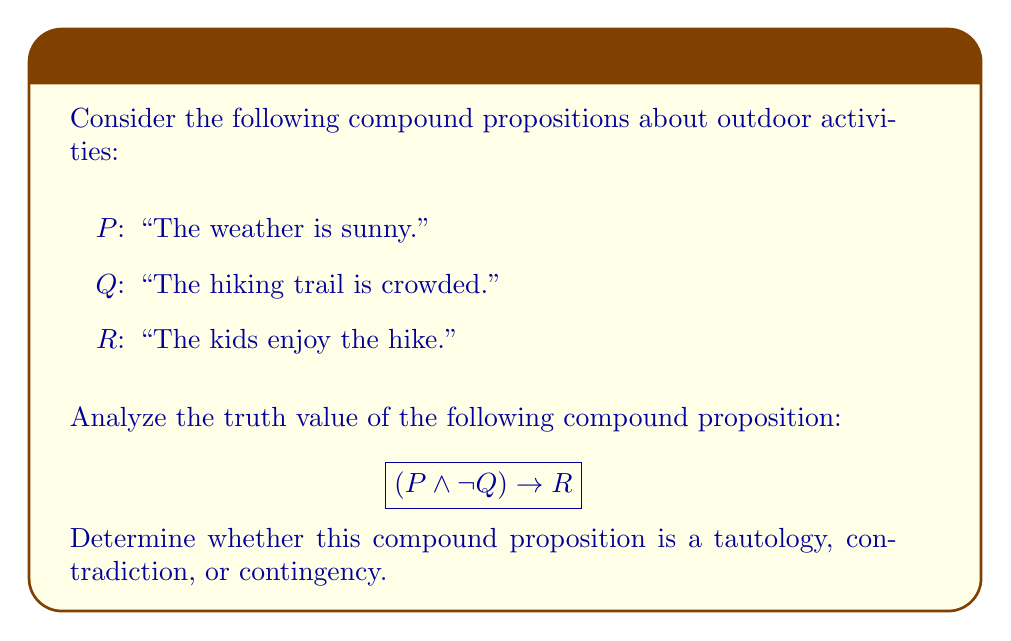Give your solution to this math problem. To analyze the truth value of the given compound proposition, we need to consider all possible combinations of truth values for P, Q, and R. We'll use a truth table to evaluate this:

1. First, let's list all possible combinations of P, Q, and R:

   | P | Q | R |
   |---|---|---|
   | T | T | T |
   | T | T | F |
   | T | F | T |
   | T | F | F |
   | F | T | T |
   | F | T | F |
   | F | F | T |
   | F | F | F |

2. Now, let's evaluate $(P \wedge \neg Q)$ for each row:

   | P | Q | $\neg Q$ | $(P \wedge \neg Q)$ |
   |---|---|---------|---------------------|
   | T | T | F       | F                   |
   | T | T | F       | F                   |
   | T | F | T       | T                   |
   | T | F | T       | T                   |
   | F | T | F       | F                   |
   | F | T | F       | F                   |
   | F | F | T       | F                   |
   | F | F | T       | F                   |

3. Finally, let's evaluate the entire compound proposition $(P \wedge \neg Q) \rightarrow R$:

   | P | Q | R | $(P \wedge \neg Q)$ | $(P \wedge \neg Q) \rightarrow R$ |
   |---|---|---|---------------------|-----------------------------------|
   | T | T | T | F                   | T                                 |
   | T | T | F | F                   | T                                 |
   | T | F | T | T                   | T                                 |
   | T | F | F | T                   | F                                 |
   | F | T | T | F                   | T                                 |
   | F | T | F | F                   | T                                 |
   | F | F | T | F                   | T                                 |
   | F | F | F | F                   | T                                 |

4. Analyzing the results:
   - The compound proposition is true in 7 out of 8 cases.
   - It is false only when P is true, Q is false, and R is false.
   - Since it is not always true, it is not a tautology.
   - Since it is not always false, it is not a contradiction.
   - As it can be either true or false depending on the truth values of P, Q, and R, it is a contingency.

This result makes sense in the context of outdoor activities with family. The proposition suggests that if the weather is sunny (P) and the trail is not crowded ($\neg Q$), then the kids enjoy the hike (R). While this is often true, it's not guaranteed, as there could be other factors affecting the kids' enjoyment of the hike.
Answer: The compound proposition $(P \wedge \neg Q) \rightarrow R$ is a contingency. 